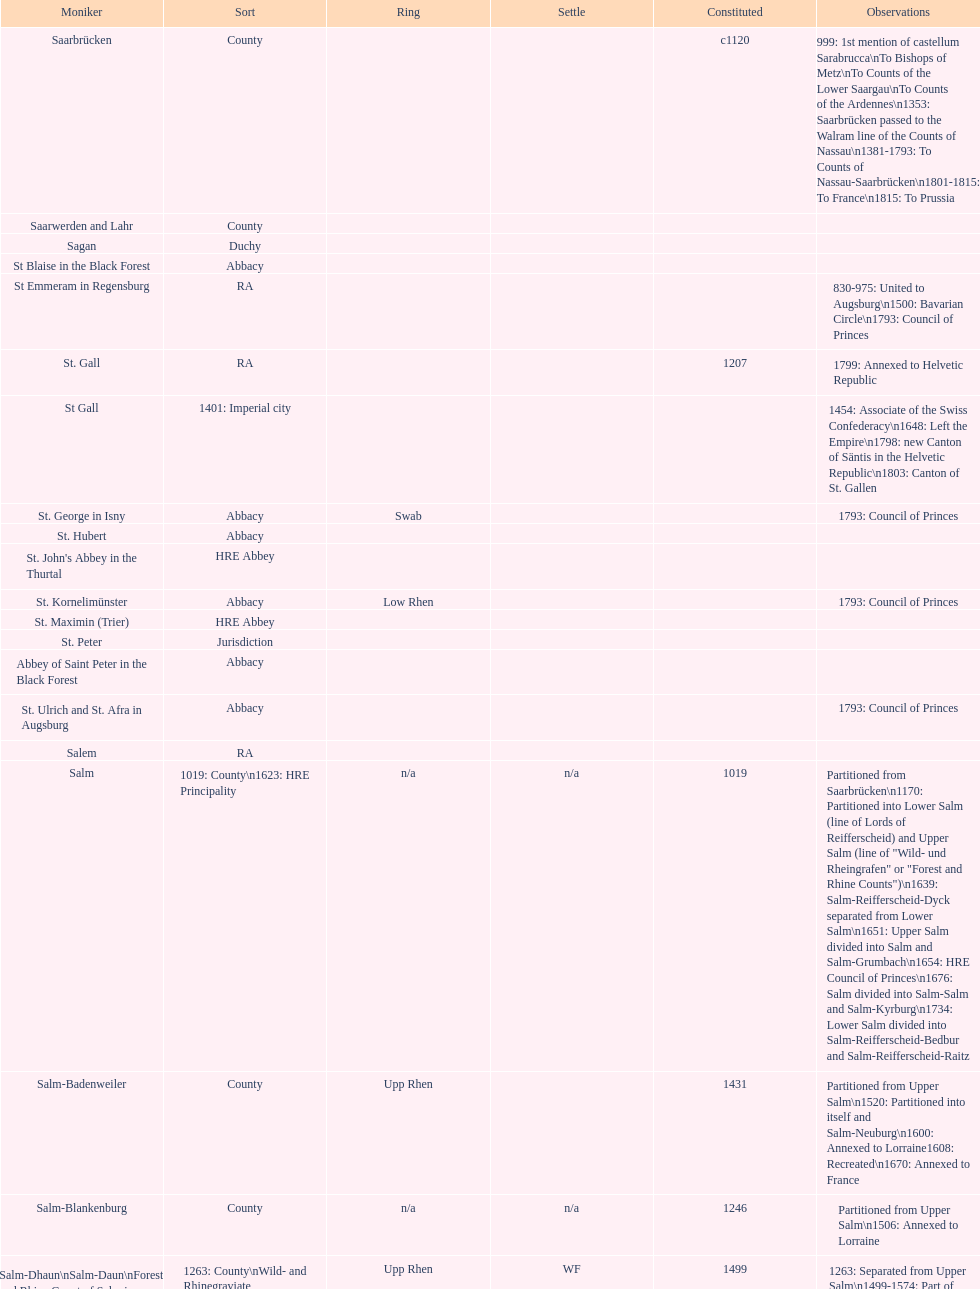How many states were of the same type as stuhlingen? 3. 